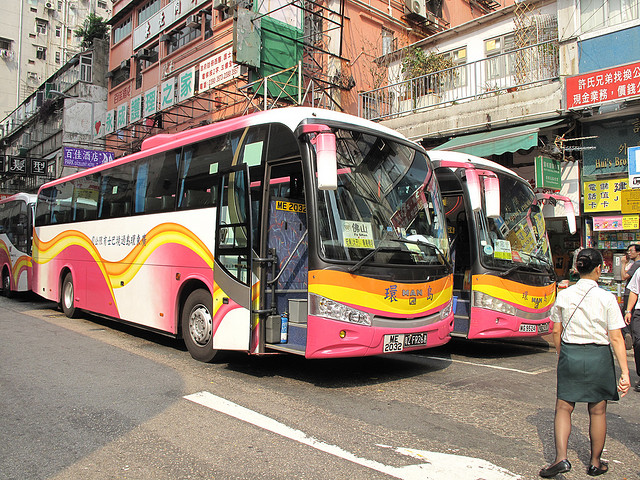Identify and read out the text in this image. ME 2032 40 3124 42 2032 ME 